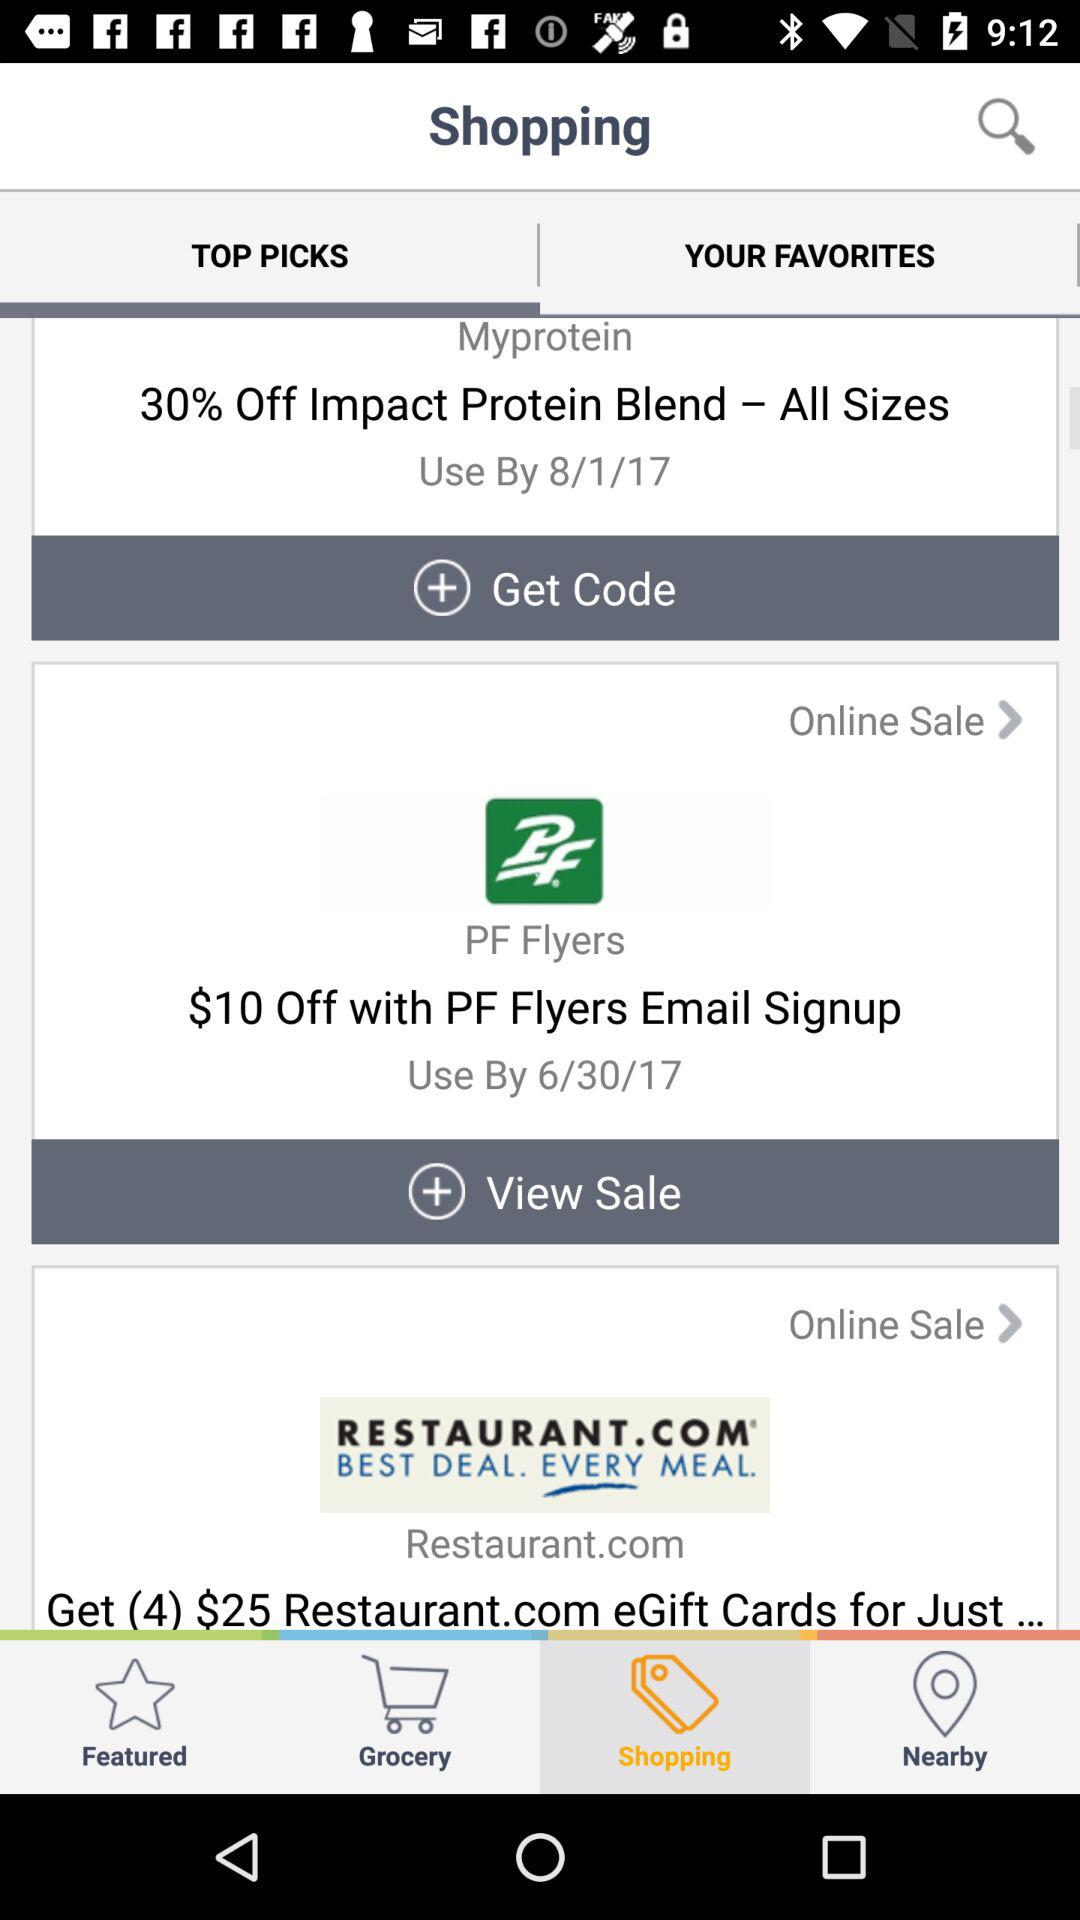What is the discount on "PF Flyers" after signing up by email? The discount is $10. 